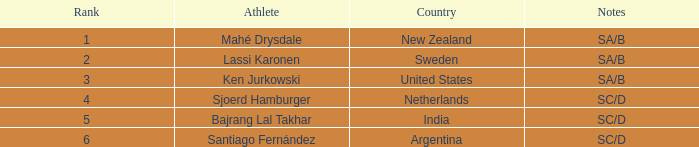What is listed in notes for the athlete, lassi karonen? SA/B. 